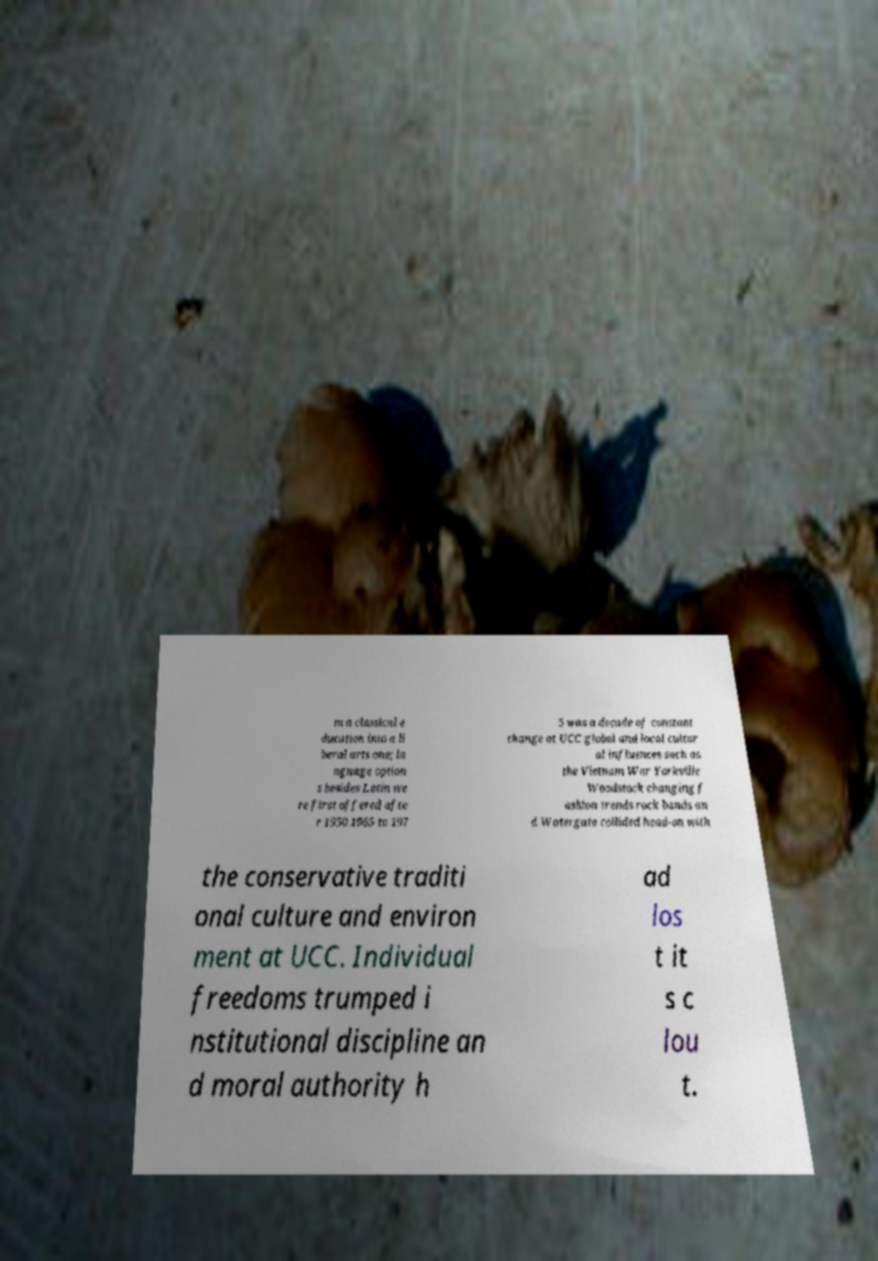Could you assist in decoding the text presented in this image and type it out clearly? m a classical e ducation into a li beral arts one; la nguage option s besides Latin we re first offered afte r 1950.1965 to 197 5 was a decade of constant change at UCC global and local cultur al influences such as the Vietnam War Yorkville Woodstock changing f ashion trends rock bands an d Watergate collided head-on with the conservative traditi onal culture and environ ment at UCC. Individual freedoms trumped i nstitutional discipline an d moral authority h ad los t it s c lou t. 